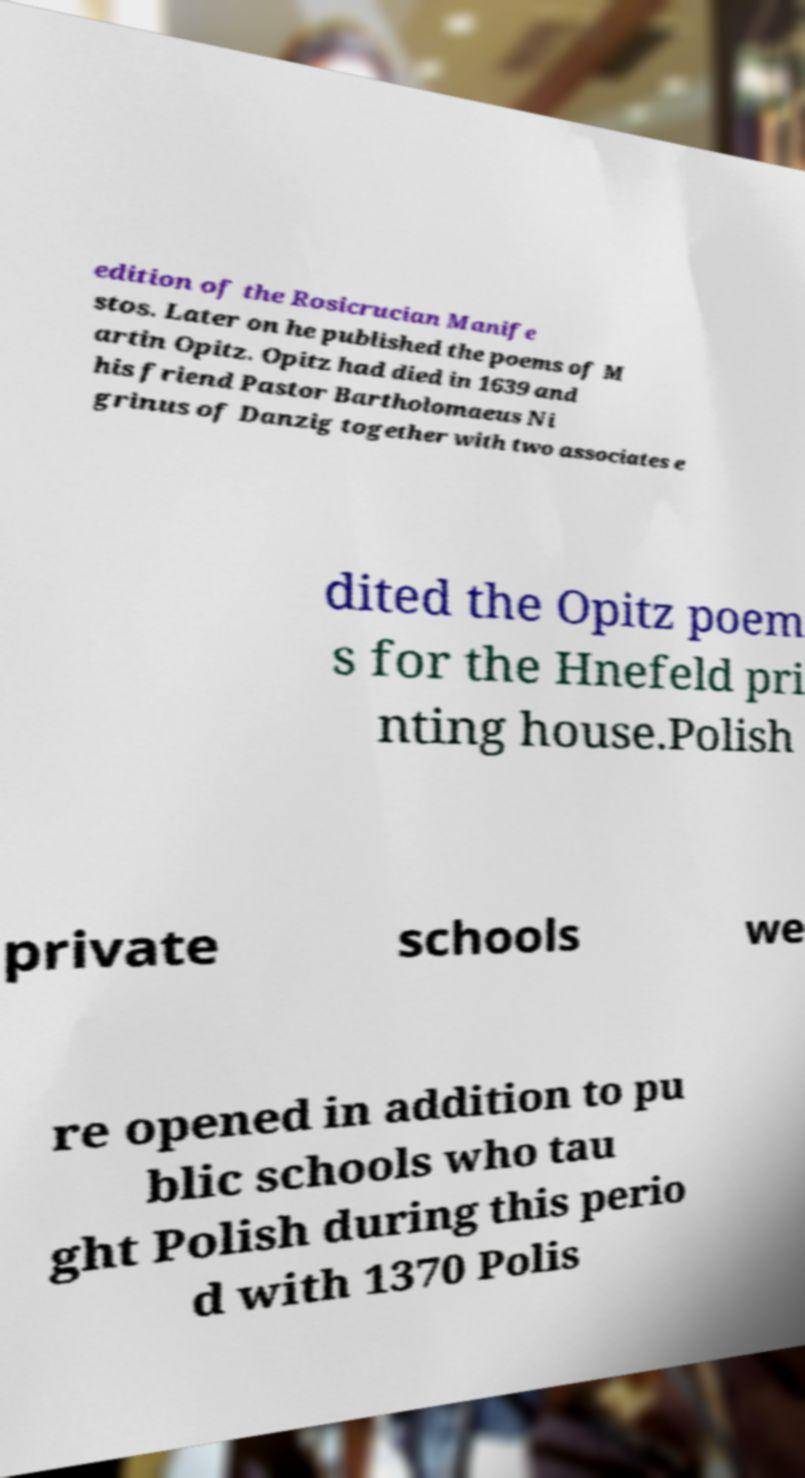What messages or text are displayed in this image? I need them in a readable, typed format. edition of the Rosicrucian Manife stos. Later on he published the poems of M artin Opitz. Opitz had died in 1639 and his friend Pastor Bartholomaeus Ni grinus of Danzig together with two associates e dited the Opitz poem s for the Hnefeld pri nting house.Polish private schools we re opened in addition to pu blic schools who tau ght Polish during this perio d with 1370 Polis 